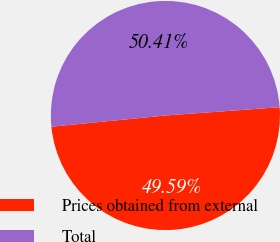Convert chart to OTSL. <chart><loc_0><loc_0><loc_500><loc_500><pie_chart><fcel>Prices obtained from external<fcel>Total<nl><fcel>49.59%<fcel>50.41%<nl></chart> 